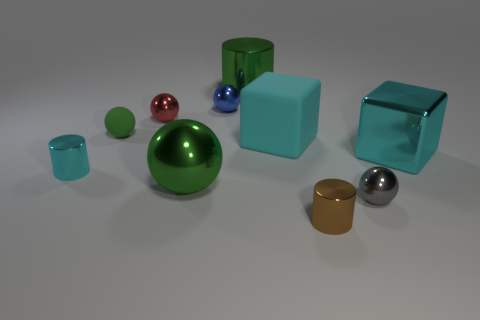Are there an equal number of large green spheres that are to the left of the tiny green ball and big green spheres that are behind the small blue ball?
Your answer should be very brief. Yes. There is another thing that is the same shape as the large cyan metallic thing; what material is it?
Make the answer very short. Rubber. There is a green metal object that is in front of the big cube that is behind the cyan metallic thing right of the small red thing; what is its shape?
Provide a short and direct response. Sphere. Is the number of tiny green things that are in front of the large metal cylinder greater than the number of large red rubber spheres?
Your answer should be compact. Yes. There is a tiny green object on the left side of the green metallic sphere; does it have the same shape as the tiny red object?
Offer a terse response. Yes. There is a tiny ball right of the small blue metal ball; what material is it?
Offer a terse response. Metal. What number of big cyan shiny things have the same shape as the blue thing?
Provide a short and direct response. 0. What is the tiny cylinder in front of the cyan metal object that is to the left of the big sphere made of?
Give a very brief answer. Metal. There is a metallic object that is the same color as the metallic block; what shape is it?
Make the answer very short. Cylinder. Is there a tiny gray cube made of the same material as the gray thing?
Your answer should be compact. No. 